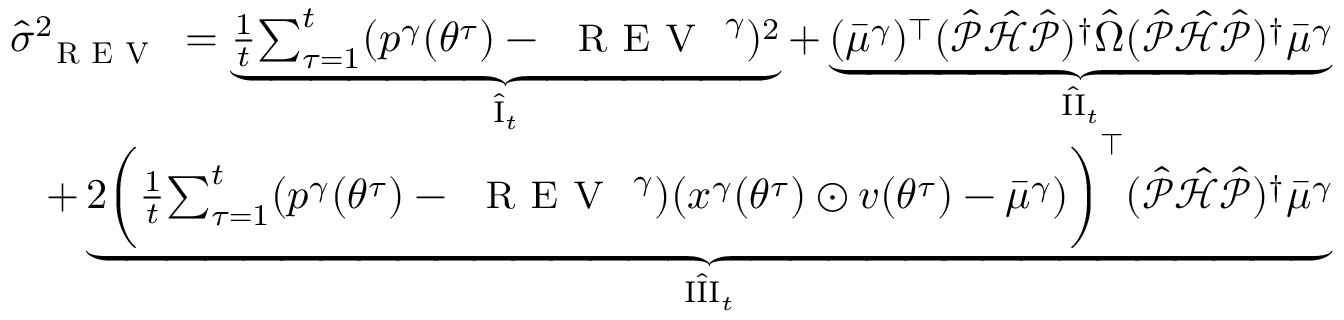<formula> <loc_0><loc_0><loc_500><loc_500>\begin{array} { r } { \hat { \sigma } _ { R E V } ^ { 2 } = \underbrace { \frac { 1 } { t } { \sum _ { \tau = 1 } ^ { t } } ( { p ^ { \gamma } } ( { \theta ^ { \tau } } ) - { R E V } ^ { \gamma } ) ^ { 2 } } _ { \hat { I } _ { t } } + \underbrace { ( { \bar { \mu } ^ { \gamma } } ) ^ { \top } ( \hat { \mathcal { P } } \hat { \mathcal { H } } \hat { \mathcal { P } } ) ^ { \dagger } \hat { \Omega } ( \hat { \mathcal { P } } \hat { \mathcal { H } } \hat { \mathcal { P } } ) ^ { \dagger } { \bar { \mu } ^ { \gamma } } } _ { \hat { I I } _ { t } } } \\ { + \underbrace { 2 \left ( \frac { 1 } { t } { \sum _ { \tau = 1 } ^ { t } } ( { p ^ { \gamma } } ( { \theta ^ { \tau } } ) - { R E V } ^ { \gamma } ) ( x ^ { \gamma } ( { \theta ^ { \tau } } ) \odot v ( { \theta ^ { \tau } } ) - { \bar { \mu } ^ { \gamma } } ) \right ) ^ { \top } ( \hat { \mathcal { P } } \hat { \mathcal { H } } \hat { \mathcal { P } } ) ^ { \dagger } { \bar { \mu } ^ { \gamma } } } _ { \hat { I I I } _ { t } } } \end{array}</formula> 